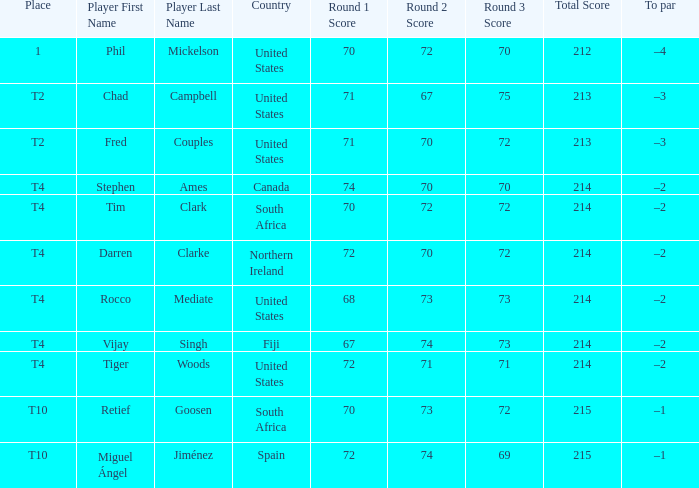What is rocco mediate's stroke standard? –2. 